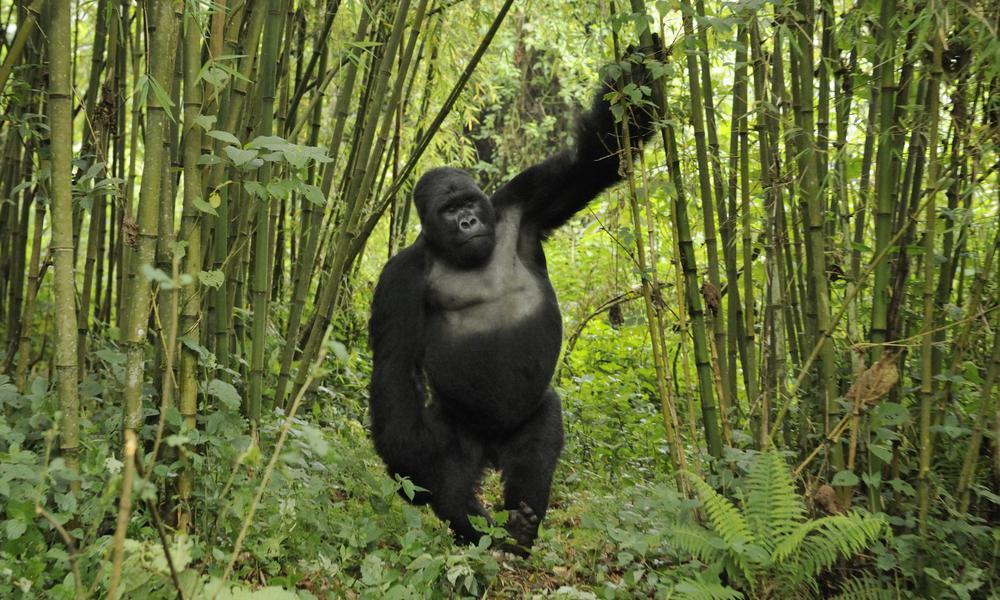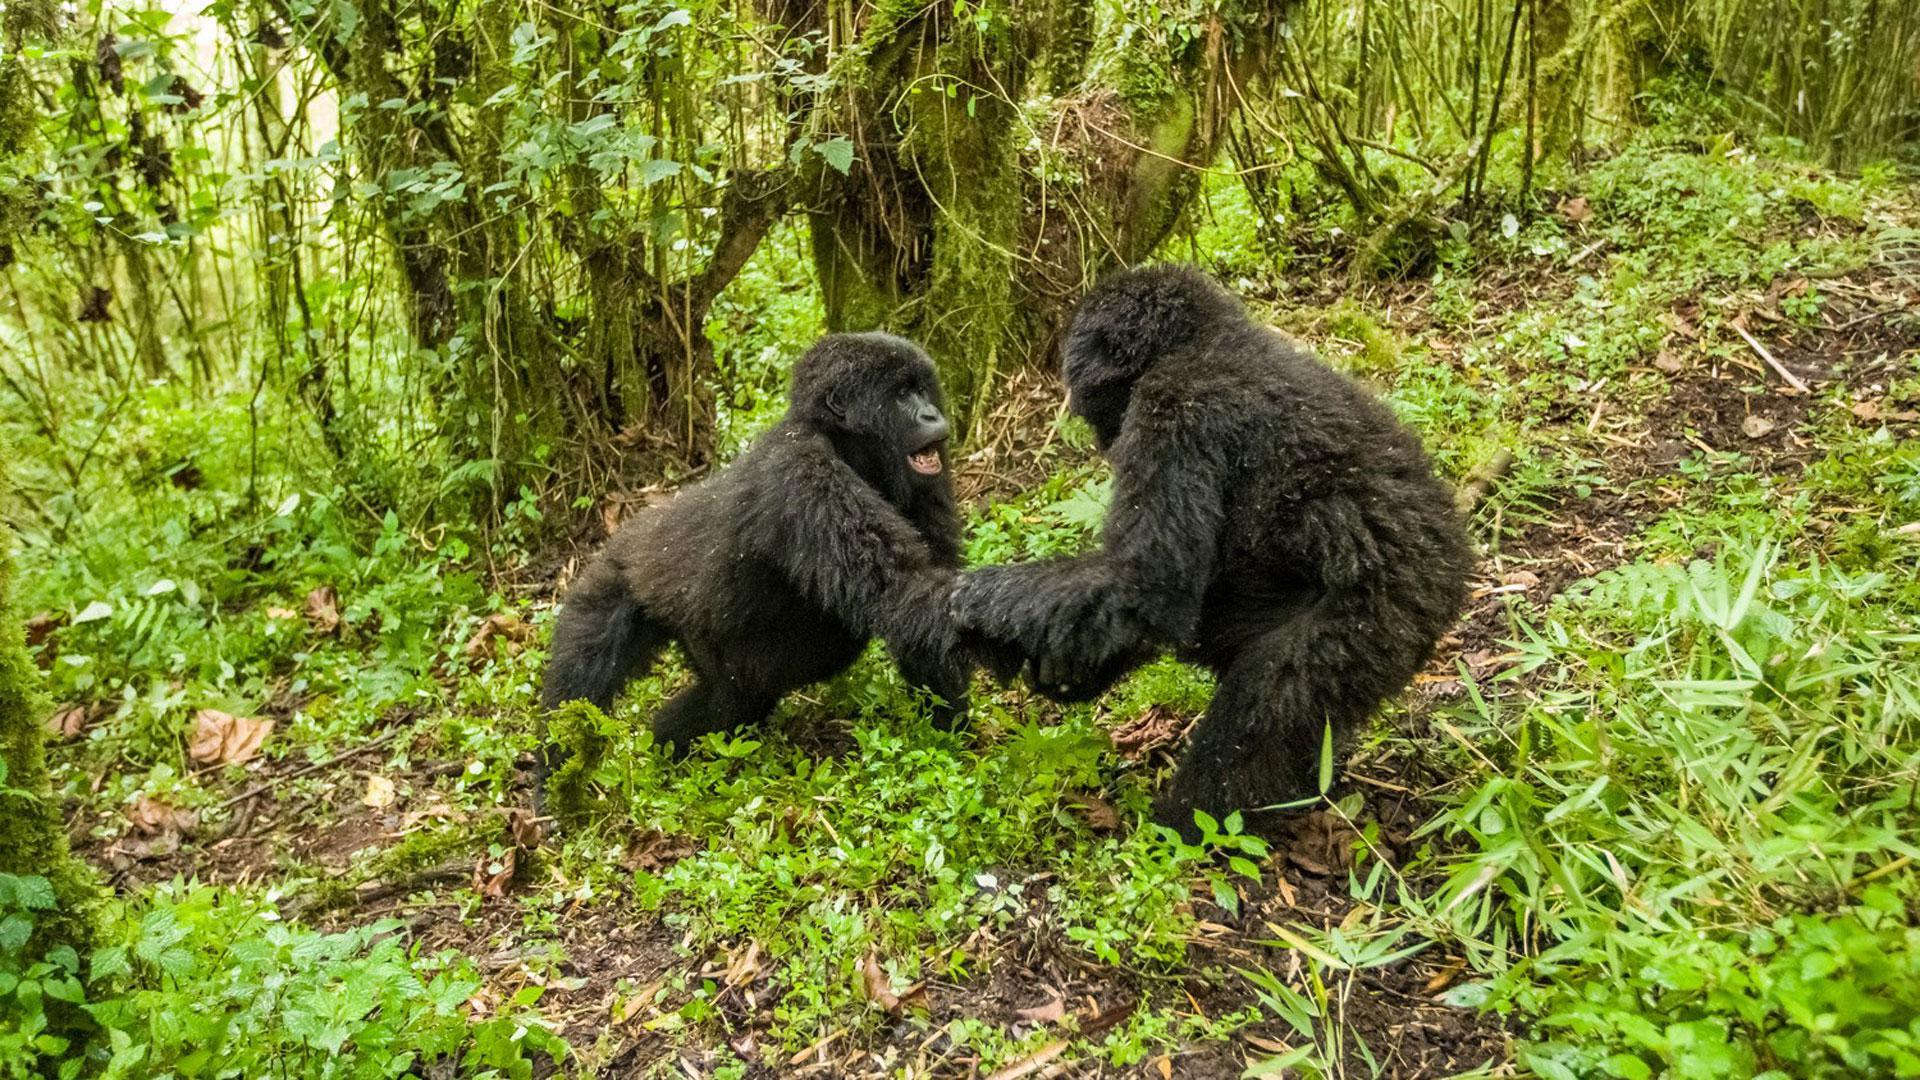The first image is the image on the left, the second image is the image on the right. Analyze the images presented: Is the assertion "An image contains exactly two gorillas, and one is behind the other facing its back but not riding on its back." valid? Answer yes or no. No. The first image is the image on the left, the second image is the image on the right. Considering the images on both sides, is "The left image contains exactly two gorillas." valid? Answer yes or no. No. 